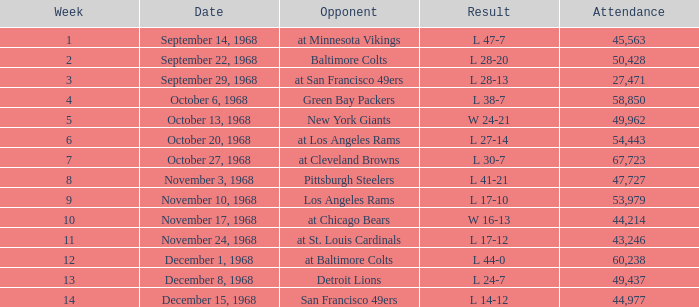Which attendance includes a rival of new york giants and a week fewer than 5? None. 